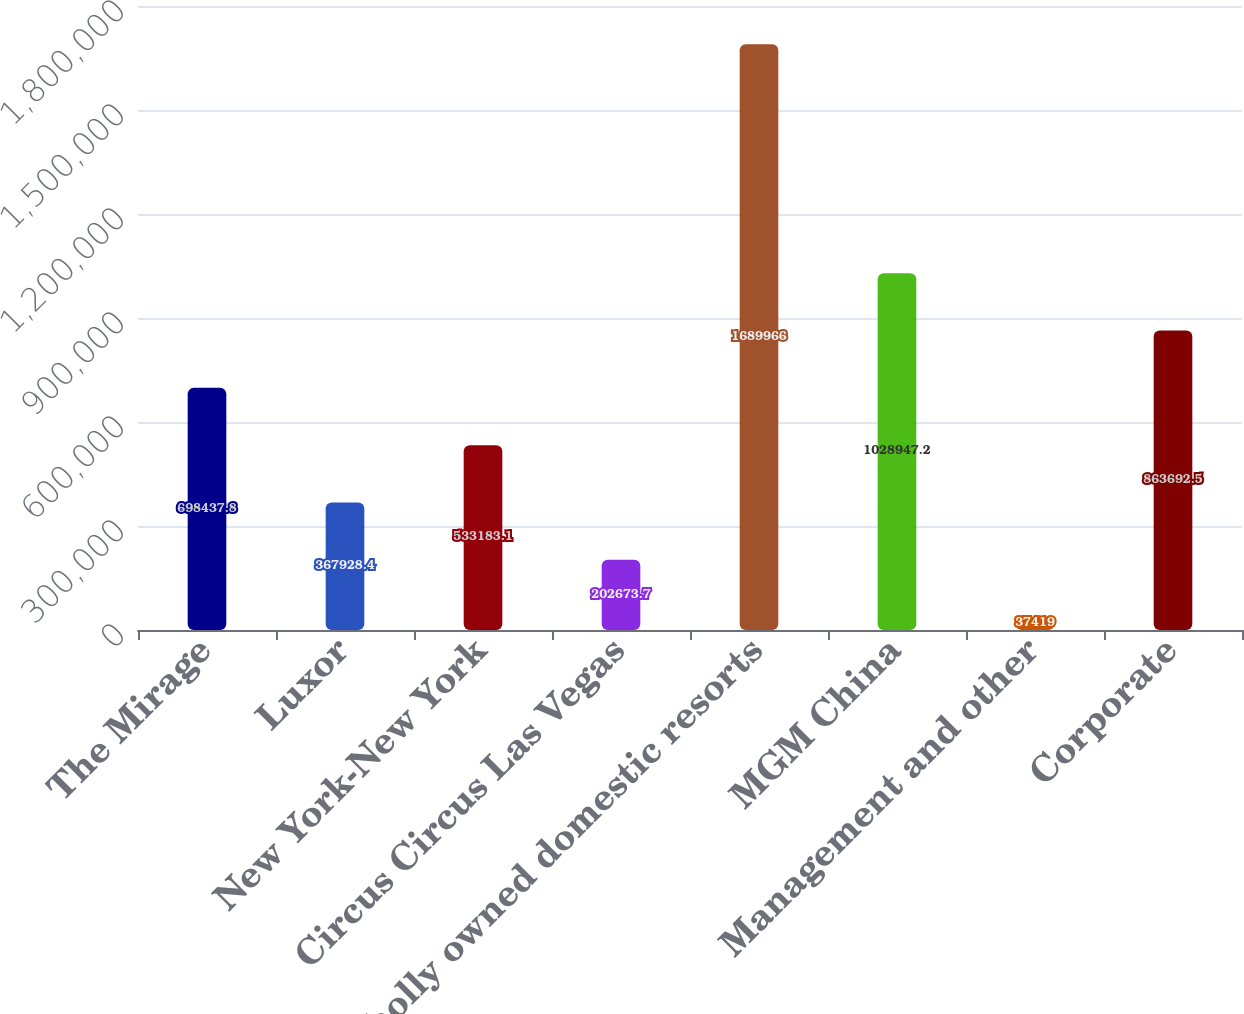<chart> <loc_0><loc_0><loc_500><loc_500><bar_chart><fcel>The Mirage<fcel>Luxor<fcel>New York-New York<fcel>Circus Circus Las Vegas<fcel>Wholly owned domestic resorts<fcel>MGM China<fcel>Management and other<fcel>Corporate<nl><fcel>698438<fcel>367928<fcel>533183<fcel>202674<fcel>1.68997e+06<fcel>1.02895e+06<fcel>37419<fcel>863692<nl></chart> 